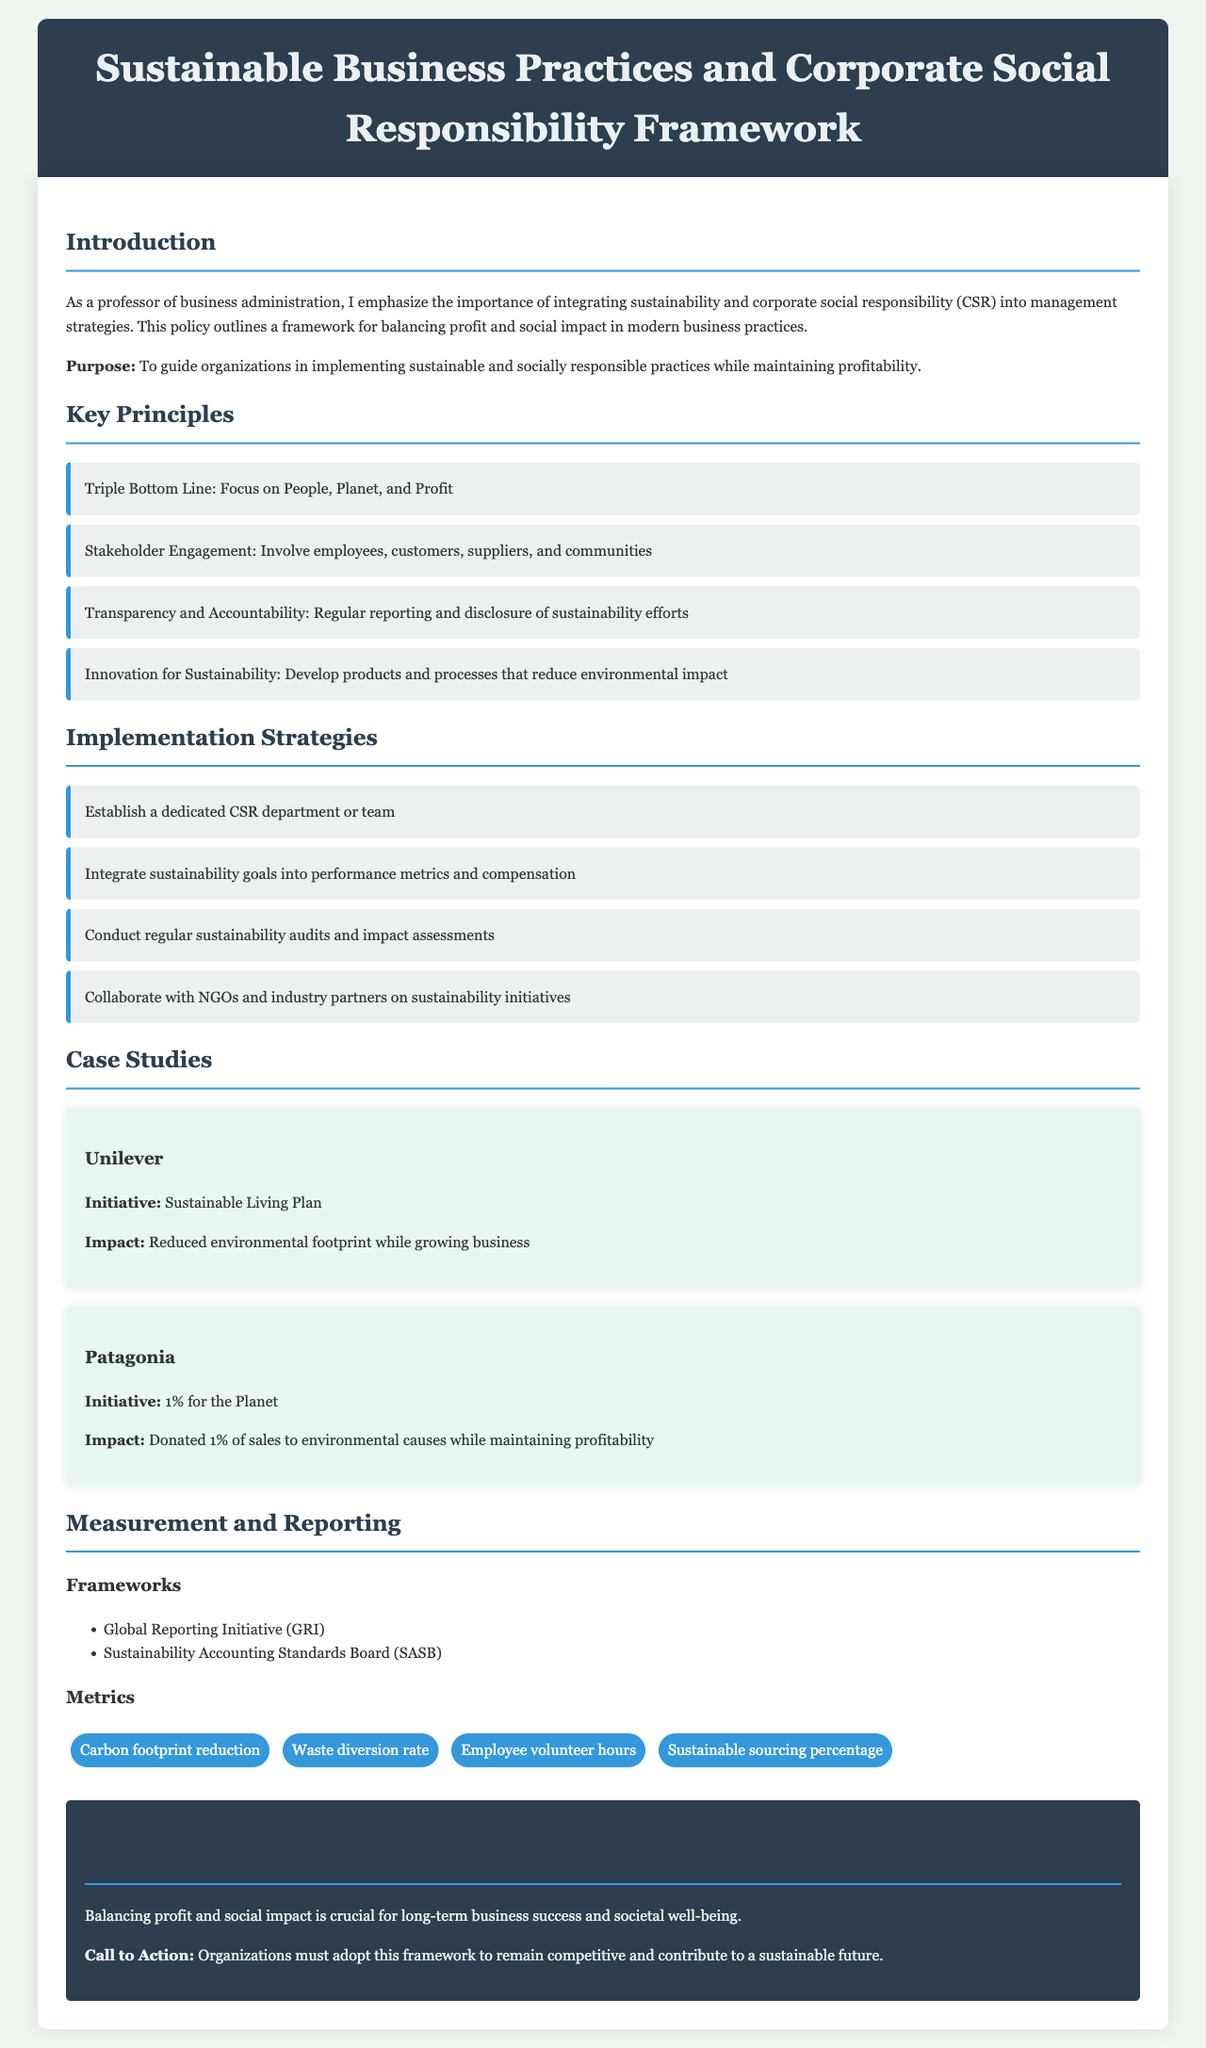What is the title of the document? The title of the document appears at the top of the content, summarizing its main focus.
Answer: Sustainable Business Practices and Corporate Social Responsibility Framework What is the key principle focused on the environment? The document lists several principles, and one directly addresses environmental considerations.
Answer: Triple Bottom Line: Focus on People, Planet, and Profit What initiative is associated with Unilever? The document contains a case study that includes the initiative taken by Unilever.
Answer: Sustainable Living Plan How many implementation strategies are listed? The section outlines the number of strategies provided for implementation of the framework.
Answer: Four What does Patagonia donate as part of their initiative? The case study for Patagonia mentions a specific percentage related to their initiative.
Answer: 1% What organization is mentioned for sustainability reporting frameworks? The document lists specific organizations that develop sustainability reporting frameworks.
Answer: Global Reporting Initiative (GRI) What metric is used to measure waste management? The metrics section includes specific factors used for evaluating sustainability practices.
Answer: Waste diversion rate What is included in the Call to Action? The conclusion contains a statement urging organizations to take a specific action.
Answer: Adopt this framework to remain competitive and contribute to a sustainable future 